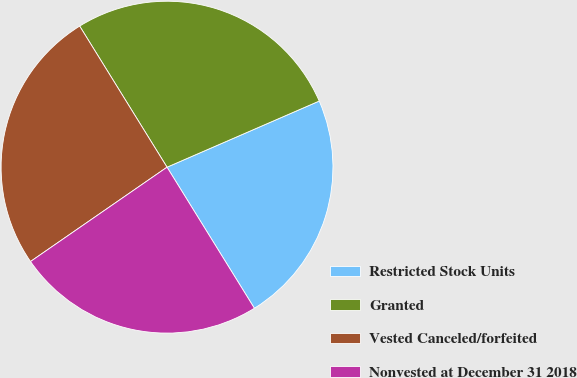Convert chart to OTSL. <chart><loc_0><loc_0><loc_500><loc_500><pie_chart><fcel>Restricted Stock Units<fcel>Granted<fcel>Vested Canceled/forfeited<fcel>Nonvested at December 31 2018<nl><fcel>22.7%<fcel>27.3%<fcel>25.8%<fcel>24.2%<nl></chart> 